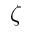Convert formula to latex. <formula><loc_0><loc_0><loc_500><loc_500>\zeta</formula> 